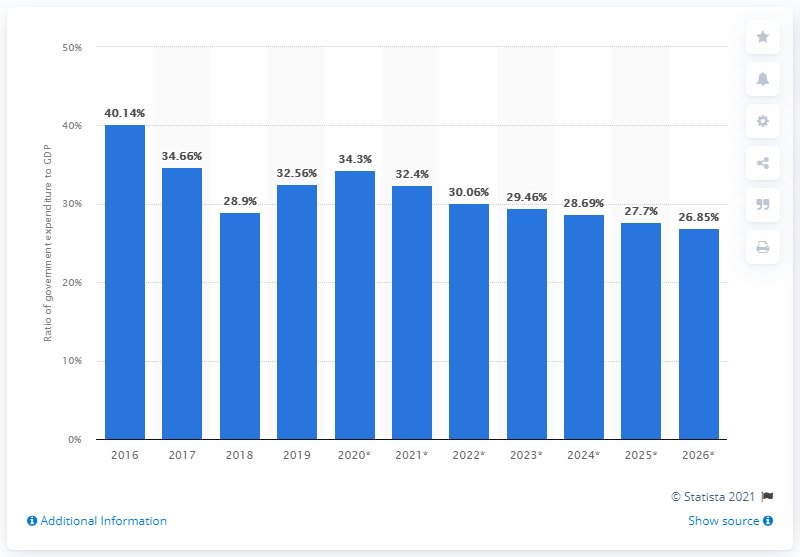Specify some key components in this picture. In 2019, government expenditure in Qatar accounted for 32.4% of the country's Gross Domestic Product (GDP). 